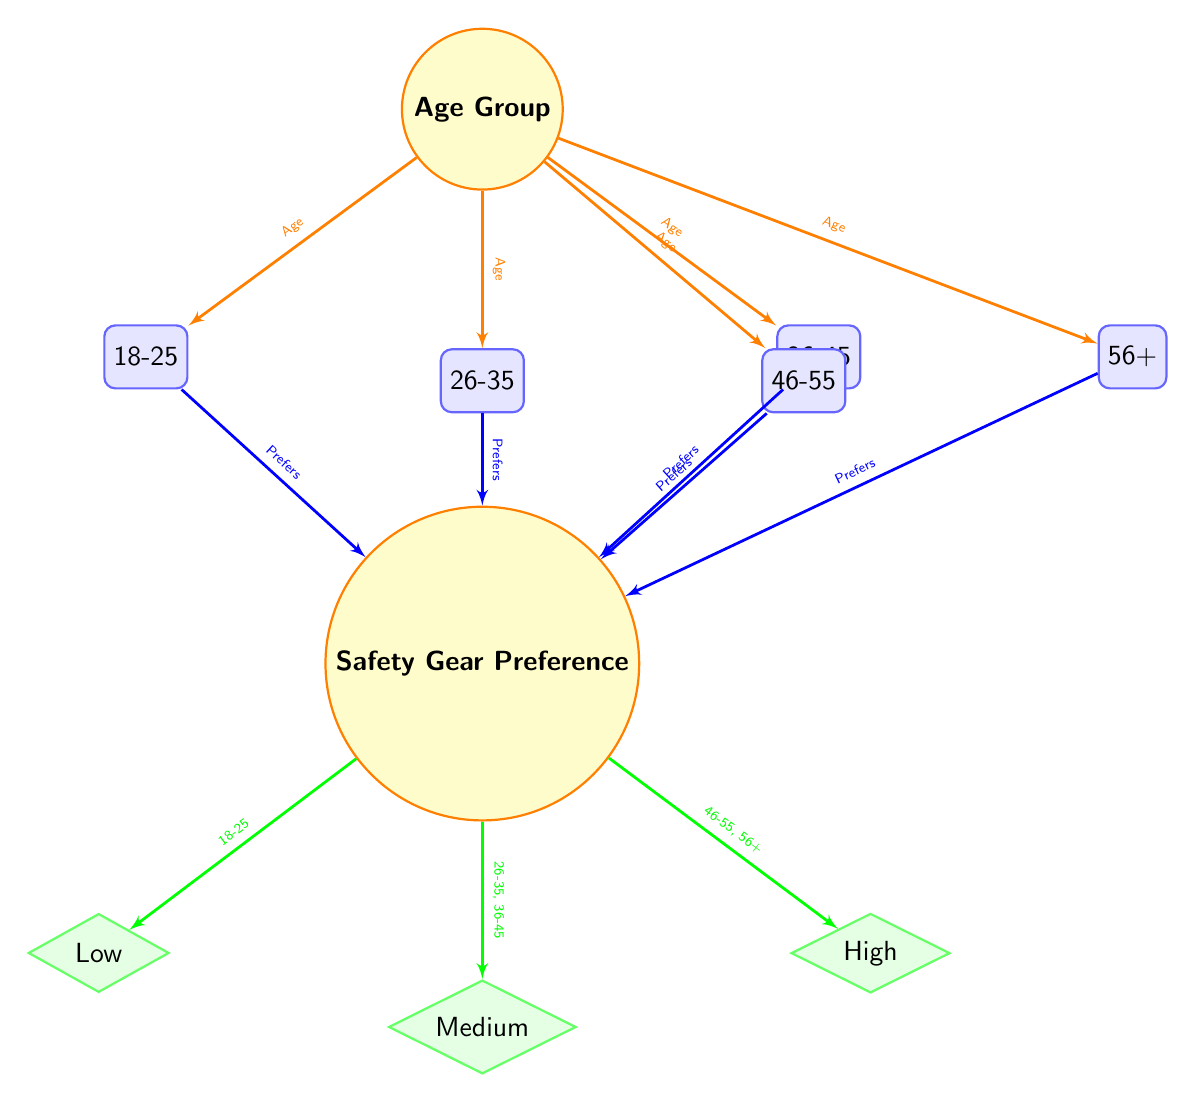What age group prefers high safety gear? By examining the preference connections, the age groups that connect to the 'High' preference for safety gear are 46-55 and 56+, indicating they are the groups that prefer high safety gear.
Answer: 46-55, 56+ How many age groups are represented in the diagram? The diagram contains five distinct age groups: 18-25, 26-35, 36-45, 46-55, and 56+. Counting these, we find there are five age groups.
Answer: 5 Which age group prefers low safety gear? The diagram indicates that only the 18-25 age group is connected to the 'Low' safety gear preference, meaning this group prefers low safety gear.
Answer: 18-25 What safety gear preference do the age groups 26-35 and 36-45 have? Both the age groups 26-35 and 36-45 connect to the 'Medium' preference for safety gear, indicating they share this preference.
Answer: Medium How many preferences for safety gear are illustrated in the diagram? The diagram illustrates three preferences for safety gear: Low, Medium, and High. This provides an overview of the varying preferences among age groups.
Answer: 3 Which age group is connected to the 'Medium' safety gear preference? The age groups that connect to the 'Medium' safety gear preference are 26-35 and 36-45, showing they both prefer this level of safety gear.
Answer: 26-35, 36-45 What is the relationship between the age group 46-55 and safety gear preference? The age group 46-55 is connected directly to the 'High' safety gear preference in the diagram, indicating that they favor high levels of safety gear.
Answer: High What color represents the age group nodes? The color used to represent the age group nodes in the diagram is blue. This blue is consistent across all age group representations.
Answer: Blue 